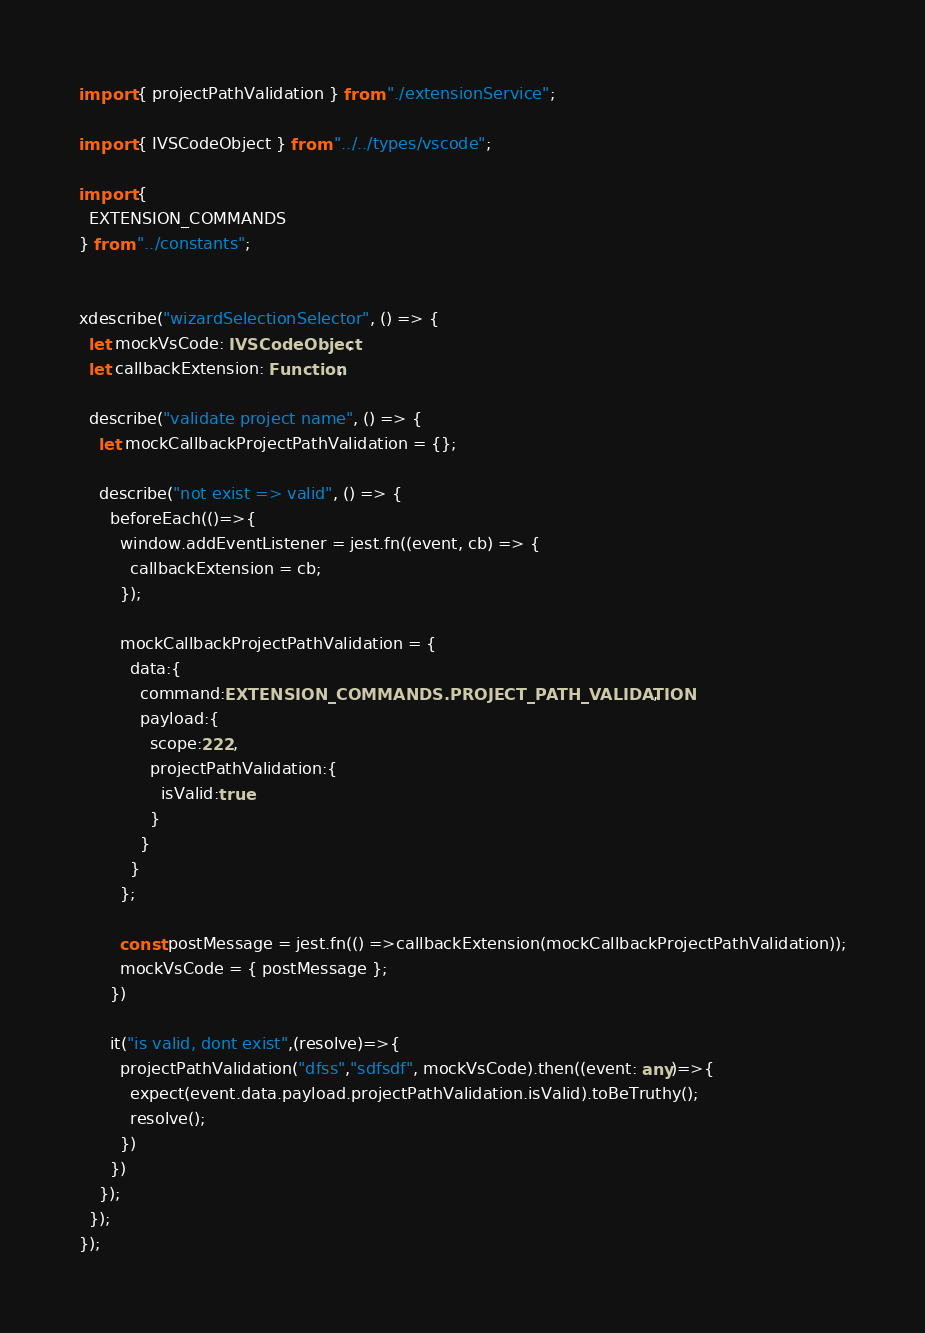<code> <loc_0><loc_0><loc_500><loc_500><_TypeScript_>
import { projectPathValidation } from "./extensionService";

import { IVSCodeObject } from "../../types/vscode";

import {
  EXTENSION_COMMANDS
} from "../constants";


xdescribe("wizardSelectionSelector", () => {
  let mockVsCode: IVSCodeObject;
  let callbackExtension: Function;

  describe("validate project name", () => {
    let mockCallbackProjectPathValidation = {};

    describe("not exist => valid", () => {
      beforeEach(()=>{
        window.addEventListener = jest.fn((event, cb) => {
          callbackExtension = cb;
        });

        mockCallbackProjectPathValidation = {
          data:{
            command:EXTENSION_COMMANDS.PROJECT_PATH_VALIDATION,
            payload:{
              scope:222,
              projectPathValidation:{
                isValid:true
              }
            }
          }
        };

        const postMessage = jest.fn(() =>callbackExtension(mockCallbackProjectPathValidation));
        mockVsCode = { postMessage };
      })

      it("is valid, dont exist",(resolve)=>{
        projectPathValidation("dfss","sdfsdf", mockVsCode).then((event: any)=>{
          expect(event.data.payload.projectPathValidation.isValid).toBeTruthy();
          resolve();
        })
      })
    });
  });
});</code> 